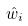Convert formula to latex. <formula><loc_0><loc_0><loc_500><loc_500>\hat { w } _ { i }</formula> 